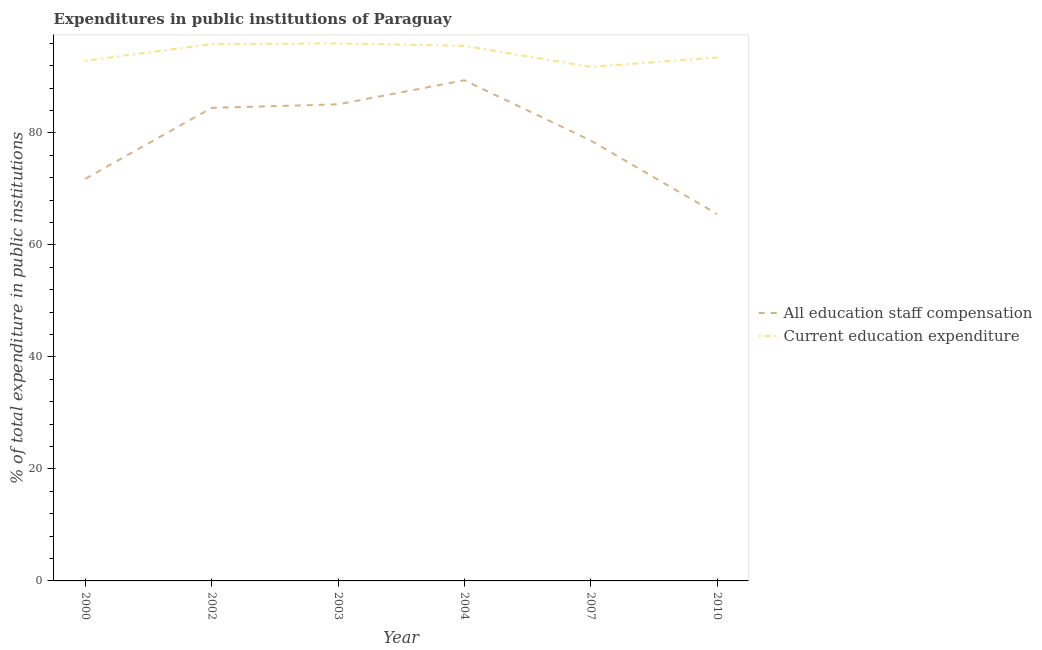Does the line corresponding to expenditure in education intersect with the line corresponding to expenditure in staff compensation?
Keep it short and to the point. No. Is the number of lines equal to the number of legend labels?
Offer a very short reply. Yes. What is the expenditure in education in 2002?
Provide a succinct answer. 95.88. Across all years, what is the maximum expenditure in education?
Ensure brevity in your answer.  96. Across all years, what is the minimum expenditure in staff compensation?
Your answer should be compact. 65.53. In which year was the expenditure in staff compensation maximum?
Offer a very short reply. 2004. In which year was the expenditure in staff compensation minimum?
Your answer should be compact. 2010. What is the total expenditure in education in the graph?
Your answer should be compact. 565.63. What is the difference between the expenditure in staff compensation in 2002 and that in 2003?
Your answer should be compact. -0.63. What is the difference between the expenditure in staff compensation in 2003 and the expenditure in education in 2000?
Provide a short and direct response. -7.79. What is the average expenditure in staff compensation per year?
Your answer should be very brief. 79.17. In the year 2007, what is the difference between the expenditure in education and expenditure in staff compensation?
Make the answer very short. 13.15. What is the ratio of the expenditure in staff compensation in 2004 to that in 2007?
Your answer should be compact. 1.14. Is the expenditure in education in 2000 less than that in 2004?
Your answer should be compact. Yes. Is the difference between the expenditure in staff compensation in 2003 and 2004 greater than the difference between the expenditure in education in 2003 and 2004?
Your answer should be very brief. No. What is the difference between the highest and the second highest expenditure in staff compensation?
Keep it short and to the point. 4.3. What is the difference between the highest and the lowest expenditure in education?
Make the answer very short. 4.2. Does the expenditure in education monotonically increase over the years?
Your answer should be very brief. No. Is the expenditure in education strictly greater than the expenditure in staff compensation over the years?
Your response must be concise. Yes. How many years are there in the graph?
Give a very brief answer. 6. Are the values on the major ticks of Y-axis written in scientific E-notation?
Offer a terse response. No. Does the graph contain grids?
Offer a very short reply. No. Where does the legend appear in the graph?
Provide a succinct answer. Center right. How many legend labels are there?
Your answer should be compact. 2. What is the title of the graph?
Ensure brevity in your answer.  Expenditures in public institutions of Paraguay. Does "Arms exports" appear as one of the legend labels in the graph?
Ensure brevity in your answer.  No. What is the label or title of the Y-axis?
Make the answer very short. % of total expenditure in public institutions. What is the % of total expenditure in public institutions of All education staff compensation in 2000?
Provide a succinct answer. 71.82. What is the % of total expenditure in public institutions in Current education expenditure in 2000?
Offer a terse response. 92.9. What is the % of total expenditure in public institutions of All education staff compensation in 2002?
Ensure brevity in your answer.  84.49. What is the % of total expenditure in public institutions of Current education expenditure in 2002?
Provide a short and direct response. 95.88. What is the % of total expenditure in public institutions in All education staff compensation in 2003?
Ensure brevity in your answer.  85.12. What is the % of total expenditure in public institutions in Current education expenditure in 2003?
Your answer should be compact. 96. What is the % of total expenditure in public institutions in All education staff compensation in 2004?
Your response must be concise. 89.41. What is the % of total expenditure in public institutions in Current education expenditure in 2004?
Offer a very short reply. 95.57. What is the % of total expenditure in public institutions in All education staff compensation in 2007?
Your answer should be very brief. 78.65. What is the % of total expenditure in public institutions of Current education expenditure in 2007?
Your response must be concise. 91.8. What is the % of total expenditure in public institutions of All education staff compensation in 2010?
Your answer should be very brief. 65.53. What is the % of total expenditure in public institutions in Current education expenditure in 2010?
Offer a very short reply. 93.48. Across all years, what is the maximum % of total expenditure in public institutions in All education staff compensation?
Provide a short and direct response. 89.41. Across all years, what is the maximum % of total expenditure in public institutions in Current education expenditure?
Provide a short and direct response. 96. Across all years, what is the minimum % of total expenditure in public institutions in All education staff compensation?
Keep it short and to the point. 65.53. Across all years, what is the minimum % of total expenditure in public institutions in Current education expenditure?
Keep it short and to the point. 91.8. What is the total % of total expenditure in public institutions in All education staff compensation in the graph?
Provide a short and direct response. 475.02. What is the total % of total expenditure in public institutions in Current education expenditure in the graph?
Give a very brief answer. 565.63. What is the difference between the % of total expenditure in public institutions of All education staff compensation in 2000 and that in 2002?
Your response must be concise. -12.67. What is the difference between the % of total expenditure in public institutions of Current education expenditure in 2000 and that in 2002?
Give a very brief answer. -2.97. What is the difference between the % of total expenditure in public institutions in All education staff compensation in 2000 and that in 2003?
Your answer should be compact. -13.3. What is the difference between the % of total expenditure in public institutions in Current education expenditure in 2000 and that in 2003?
Keep it short and to the point. -3.1. What is the difference between the % of total expenditure in public institutions in All education staff compensation in 2000 and that in 2004?
Provide a succinct answer. -17.59. What is the difference between the % of total expenditure in public institutions in Current education expenditure in 2000 and that in 2004?
Your answer should be very brief. -2.66. What is the difference between the % of total expenditure in public institutions in All education staff compensation in 2000 and that in 2007?
Make the answer very short. -6.83. What is the difference between the % of total expenditure in public institutions of Current education expenditure in 2000 and that in 2007?
Make the answer very short. 1.1. What is the difference between the % of total expenditure in public institutions of All education staff compensation in 2000 and that in 2010?
Your response must be concise. 6.29. What is the difference between the % of total expenditure in public institutions of Current education expenditure in 2000 and that in 2010?
Keep it short and to the point. -0.58. What is the difference between the % of total expenditure in public institutions of All education staff compensation in 2002 and that in 2003?
Your answer should be very brief. -0.63. What is the difference between the % of total expenditure in public institutions in Current education expenditure in 2002 and that in 2003?
Offer a very short reply. -0.12. What is the difference between the % of total expenditure in public institutions in All education staff compensation in 2002 and that in 2004?
Keep it short and to the point. -4.93. What is the difference between the % of total expenditure in public institutions in Current education expenditure in 2002 and that in 2004?
Your response must be concise. 0.31. What is the difference between the % of total expenditure in public institutions in All education staff compensation in 2002 and that in 2007?
Make the answer very short. 5.84. What is the difference between the % of total expenditure in public institutions in Current education expenditure in 2002 and that in 2007?
Ensure brevity in your answer.  4.08. What is the difference between the % of total expenditure in public institutions in All education staff compensation in 2002 and that in 2010?
Provide a succinct answer. 18.96. What is the difference between the % of total expenditure in public institutions in Current education expenditure in 2002 and that in 2010?
Provide a short and direct response. 2.39. What is the difference between the % of total expenditure in public institutions in All education staff compensation in 2003 and that in 2004?
Your answer should be very brief. -4.3. What is the difference between the % of total expenditure in public institutions of Current education expenditure in 2003 and that in 2004?
Your answer should be compact. 0.44. What is the difference between the % of total expenditure in public institutions of All education staff compensation in 2003 and that in 2007?
Provide a succinct answer. 6.47. What is the difference between the % of total expenditure in public institutions of Current education expenditure in 2003 and that in 2007?
Give a very brief answer. 4.2. What is the difference between the % of total expenditure in public institutions of All education staff compensation in 2003 and that in 2010?
Offer a very short reply. 19.59. What is the difference between the % of total expenditure in public institutions in Current education expenditure in 2003 and that in 2010?
Ensure brevity in your answer.  2.52. What is the difference between the % of total expenditure in public institutions in All education staff compensation in 2004 and that in 2007?
Offer a terse response. 10.76. What is the difference between the % of total expenditure in public institutions in Current education expenditure in 2004 and that in 2007?
Offer a terse response. 3.76. What is the difference between the % of total expenditure in public institutions in All education staff compensation in 2004 and that in 2010?
Keep it short and to the point. 23.89. What is the difference between the % of total expenditure in public institutions of Current education expenditure in 2004 and that in 2010?
Your answer should be compact. 2.08. What is the difference between the % of total expenditure in public institutions of All education staff compensation in 2007 and that in 2010?
Keep it short and to the point. 13.12. What is the difference between the % of total expenditure in public institutions of Current education expenditure in 2007 and that in 2010?
Ensure brevity in your answer.  -1.68. What is the difference between the % of total expenditure in public institutions in All education staff compensation in 2000 and the % of total expenditure in public institutions in Current education expenditure in 2002?
Your answer should be compact. -24.06. What is the difference between the % of total expenditure in public institutions in All education staff compensation in 2000 and the % of total expenditure in public institutions in Current education expenditure in 2003?
Offer a very short reply. -24.18. What is the difference between the % of total expenditure in public institutions of All education staff compensation in 2000 and the % of total expenditure in public institutions of Current education expenditure in 2004?
Offer a terse response. -23.74. What is the difference between the % of total expenditure in public institutions in All education staff compensation in 2000 and the % of total expenditure in public institutions in Current education expenditure in 2007?
Ensure brevity in your answer.  -19.98. What is the difference between the % of total expenditure in public institutions in All education staff compensation in 2000 and the % of total expenditure in public institutions in Current education expenditure in 2010?
Ensure brevity in your answer.  -21.66. What is the difference between the % of total expenditure in public institutions in All education staff compensation in 2002 and the % of total expenditure in public institutions in Current education expenditure in 2003?
Provide a short and direct response. -11.51. What is the difference between the % of total expenditure in public institutions in All education staff compensation in 2002 and the % of total expenditure in public institutions in Current education expenditure in 2004?
Your answer should be compact. -11.08. What is the difference between the % of total expenditure in public institutions of All education staff compensation in 2002 and the % of total expenditure in public institutions of Current education expenditure in 2007?
Provide a succinct answer. -7.31. What is the difference between the % of total expenditure in public institutions in All education staff compensation in 2002 and the % of total expenditure in public institutions in Current education expenditure in 2010?
Ensure brevity in your answer.  -8.99. What is the difference between the % of total expenditure in public institutions in All education staff compensation in 2003 and the % of total expenditure in public institutions in Current education expenditure in 2004?
Ensure brevity in your answer.  -10.45. What is the difference between the % of total expenditure in public institutions of All education staff compensation in 2003 and the % of total expenditure in public institutions of Current education expenditure in 2007?
Provide a succinct answer. -6.68. What is the difference between the % of total expenditure in public institutions of All education staff compensation in 2003 and the % of total expenditure in public institutions of Current education expenditure in 2010?
Ensure brevity in your answer.  -8.37. What is the difference between the % of total expenditure in public institutions in All education staff compensation in 2004 and the % of total expenditure in public institutions in Current education expenditure in 2007?
Your response must be concise. -2.39. What is the difference between the % of total expenditure in public institutions of All education staff compensation in 2004 and the % of total expenditure in public institutions of Current education expenditure in 2010?
Your response must be concise. -4.07. What is the difference between the % of total expenditure in public institutions of All education staff compensation in 2007 and the % of total expenditure in public institutions of Current education expenditure in 2010?
Offer a terse response. -14.83. What is the average % of total expenditure in public institutions of All education staff compensation per year?
Your response must be concise. 79.17. What is the average % of total expenditure in public institutions in Current education expenditure per year?
Your answer should be compact. 94.27. In the year 2000, what is the difference between the % of total expenditure in public institutions in All education staff compensation and % of total expenditure in public institutions in Current education expenditure?
Offer a very short reply. -21.08. In the year 2002, what is the difference between the % of total expenditure in public institutions in All education staff compensation and % of total expenditure in public institutions in Current education expenditure?
Your answer should be compact. -11.39. In the year 2003, what is the difference between the % of total expenditure in public institutions in All education staff compensation and % of total expenditure in public institutions in Current education expenditure?
Give a very brief answer. -10.88. In the year 2004, what is the difference between the % of total expenditure in public institutions in All education staff compensation and % of total expenditure in public institutions in Current education expenditure?
Offer a very short reply. -6.15. In the year 2007, what is the difference between the % of total expenditure in public institutions of All education staff compensation and % of total expenditure in public institutions of Current education expenditure?
Your response must be concise. -13.15. In the year 2010, what is the difference between the % of total expenditure in public institutions of All education staff compensation and % of total expenditure in public institutions of Current education expenditure?
Offer a very short reply. -27.96. What is the ratio of the % of total expenditure in public institutions in All education staff compensation in 2000 to that in 2002?
Ensure brevity in your answer.  0.85. What is the ratio of the % of total expenditure in public institutions of All education staff compensation in 2000 to that in 2003?
Keep it short and to the point. 0.84. What is the ratio of the % of total expenditure in public institutions of Current education expenditure in 2000 to that in 2003?
Your answer should be compact. 0.97. What is the ratio of the % of total expenditure in public institutions in All education staff compensation in 2000 to that in 2004?
Offer a terse response. 0.8. What is the ratio of the % of total expenditure in public institutions in Current education expenditure in 2000 to that in 2004?
Ensure brevity in your answer.  0.97. What is the ratio of the % of total expenditure in public institutions in All education staff compensation in 2000 to that in 2007?
Make the answer very short. 0.91. What is the ratio of the % of total expenditure in public institutions of Current education expenditure in 2000 to that in 2007?
Give a very brief answer. 1.01. What is the ratio of the % of total expenditure in public institutions in All education staff compensation in 2000 to that in 2010?
Ensure brevity in your answer.  1.1. What is the ratio of the % of total expenditure in public institutions of Current education expenditure in 2000 to that in 2010?
Make the answer very short. 0.99. What is the ratio of the % of total expenditure in public institutions in Current education expenditure in 2002 to that in 2003?
Offer a very short reply. 1. What is the ratio of the % of total expenditure in public institutions of All education staff compensation in 2002 to that in 2004?
Your answer should be very brief. 0.94. What is the ratio of the % of total expenditure in public institutions of All education staff compensation in 2002 to that in 2007?
Make the answer very short. 1.07. What is the ratio of the % of total expenditure in public institutions in Current education expenditure in 2002 to that in 2007?
Offer a very short reply. 1.04. What is the ratio of the % of total expenditure in public institutions of All education staff compensation in 2002 to that in 2010?
Offer a terse response. 1.29. What is the ratio of the % of total expenditure in public institutions of Current education expenditure in 2002 to that in 2010?
Ensure brevity in your answer.  1.03. What is the ratio of the % of total expenditure in public institutions in Current education expenditure in 2003 to that in 2004?
Give a very brief answer. 1. What is the ratio of the % of total expenditure in public institutions in All education staff compensation in 2003 to that in 2007?
Give a very brief answer. 1.08. What is the ratio of the % of total expenditure in public institutions of Current education expenditure in 2003 to that in 2007?
Your answer should be compact. 1.05. What is the ratio of the % of total expenditure in public institutions in All education staff compensation in 2003 to that in 2010?
Offer a terse response. 1.3. What is the ratio of the % of total expenditure in public institutions in Current education expenditure in 2003 to that in 2010?
Provide a succinct answer. 1.03. What is the ratio of the % of total expenditure in public institutions of All education staff compensation in 2004 to that in 2007?
Provide a short and direct response. 1.14. What is the ratio of the % of total expenditure in public institutions in Current education expenditure in 2004 to that in 2007?
Ensure brevity in your answer.  1.04. What is the ratio of the % of total expenditure in public institutions in All education staff compensation in 2004 to that in 2010?
Your response must be concise. 1.36. What is the ratio of the % of total expenditure in public institutions of Current education expenditure in 2004 to that in 2010?
Your response must be concise. 1.02. What is the ratio of the % of total expenditure in public institutions of All education staff compensation in 2007 to that in 2010?
Provide a succinct answer. 1.2. What is the difference between the highest and the second highest % of total expenditure in public institutions of All education staff compensation?
Your answer should be very brief. 4.3. What is the difference between the highest and the second highest % of total expenditure in public institutions of Current education expenditure?
Ensure brevity in your answer.  0.12. What is the difference between the highest and the lowest % of total expenditure in public institutions of All education staff compensation?
Provide a succinct answer. 23.89. What is the difference between the highest and the lowest % of total expenditure in public institutions in Current education expenditure?
Offer a very short reply. 4.2. 